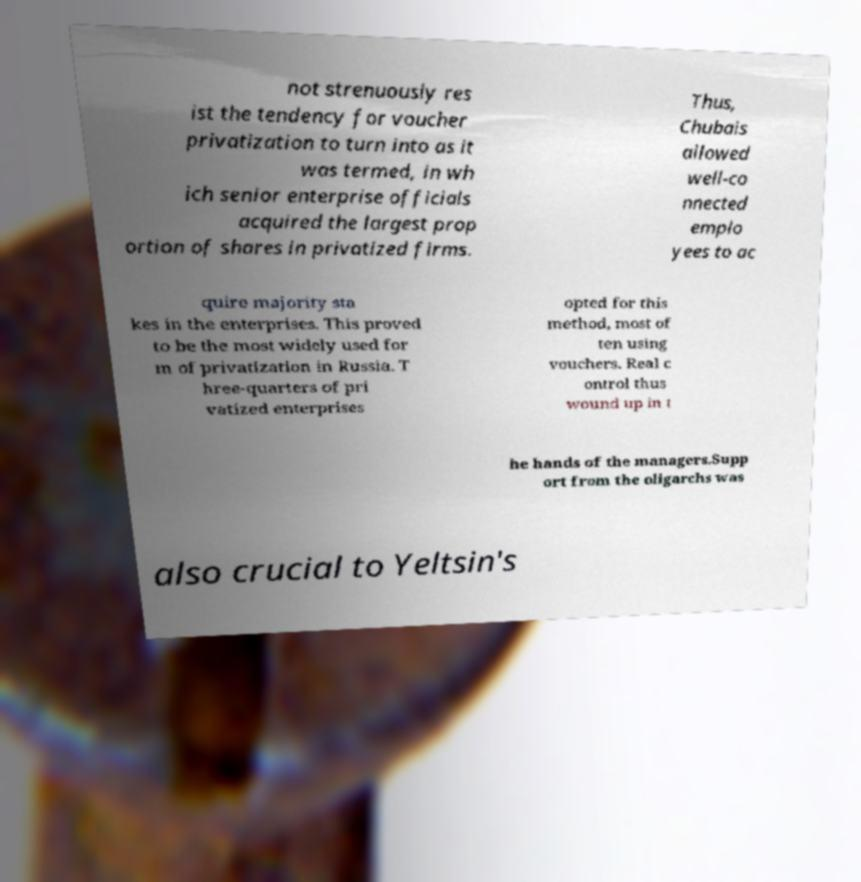There's text embedded in this image that I need extracted. Can you transcribe it verbatim? not strenuously res ist the tendency for voucher privatization to turn into as it was termed, in wh ich senior enterprise officials acquired the largest prop ortion of shares in privatized firms. Thus, Chubais allowed well-co nnected emplo yees to ac quire majority sta kes in the enterprises. This proved to be the most widely used for m of privatization in Russia. T hree-quarters of pri vatized enterprises opted for this method, most of ten using vouchers. Real c ontrol thus wound up in t he hands of the managers.Supp ort from the oligarchs was also crucial to Yeltsin's 